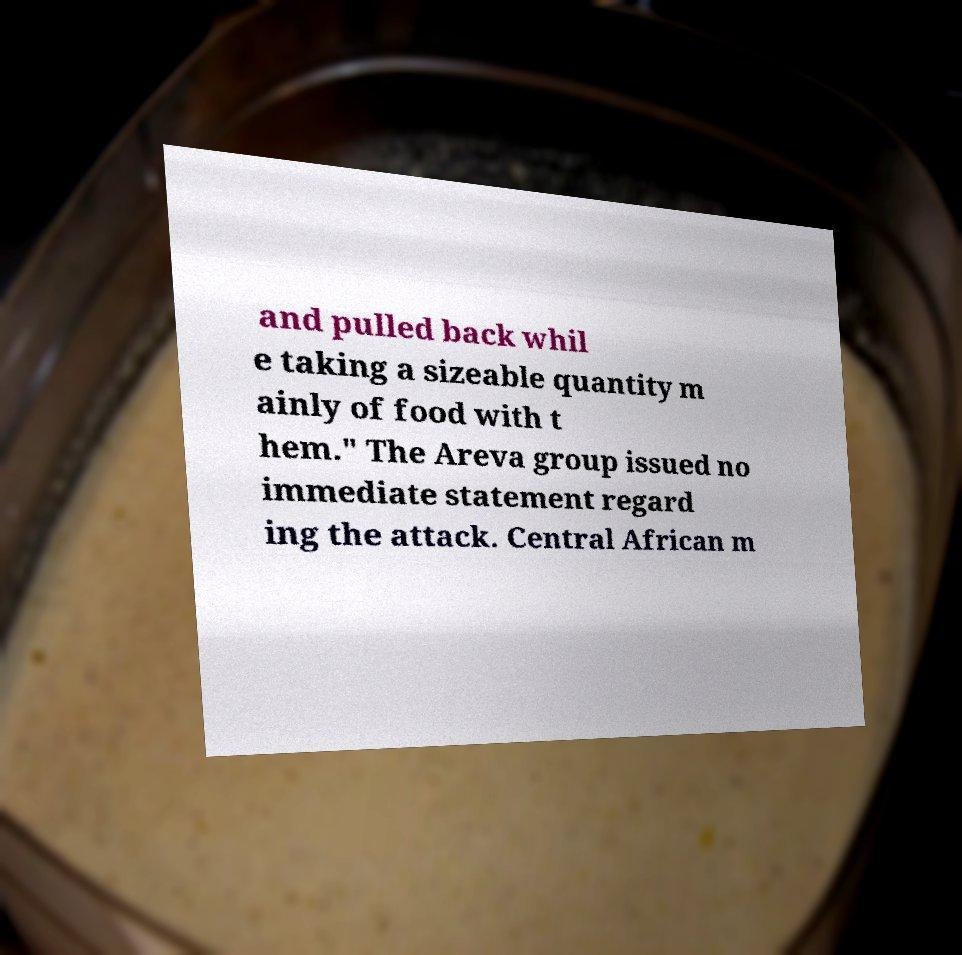What messages or text are displayed in this image? I need them in a readable, typed format. and pulled back whil e taking a sizeable quantity m ainly of food with t hem." The Areva group issued no immediate statement regard ing the attack. Central African m 